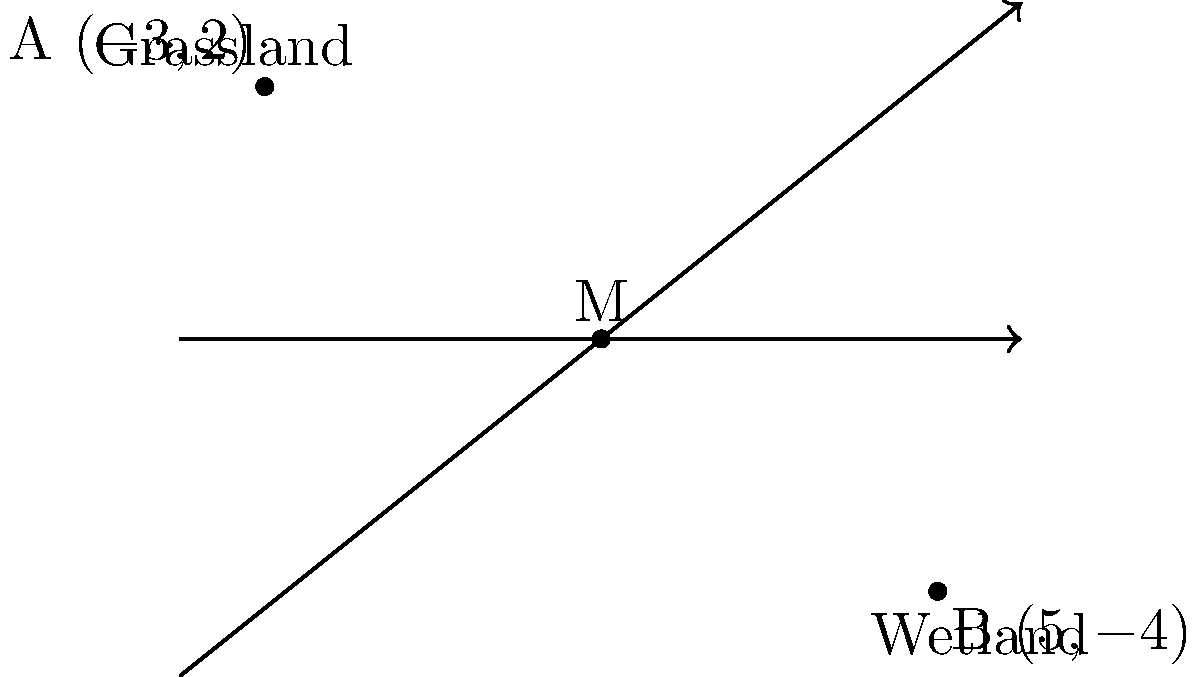In an environmental study, two distinct ecosystems are represented on a coordinate plane. The grassland ecosystem is located at point A(-3, 2), while the wetland ecosystem is at point B(5, -4). Calculate the coordinates of point M, which represents the midpoint of the line segment connecting these two ecosystems. How might this midpoint be relevant in studying the transition between these ecosystems? To find the midpoint M of the line segment AB, we use the midpoint formula:

$$ M_x = \frac{x_1 + x_2}{2}, \quad M_y = \frac{y_1 + y_2}{2} $$

Where $(x_1, y_1)$ are the coordinates of point A, and $(x_2, y_2)$ are the coordinates of point B.

Step 1: Calculate the x-coordinate of the midpoint:
$$ M_x = \frac{-3 + 5}{2} = \frac{2}{2} = 1 $$

Step 2: Calculate the y-coordinate of the midpoint:
$$ M_y = \frac{2 + (-4)}{2} = \frac{-2}{2} = -1 $$

Therefore, the coordinates of the midpoint M are (1, -1).

Relevance to ecosystem transition:
The midpoint M(1, -1) represents an area where characteristics of both grassland and wetland ecosystems might blend. This could be an ecotone, a transition zone between two different ecosystems. Studying this area could provide insights into:

1. Species diversity in transition zones
2. Gradual changes in soil composition and hydrology
3. Adaptation of species to mixed environmental conditions
4. The impact of climate change on ecosystem boundaries

Understanding these transition zones is crucial for environmental science students to grasp the complexity of ecosystem interactions and boundaries.
Answer: M(1, -1) 